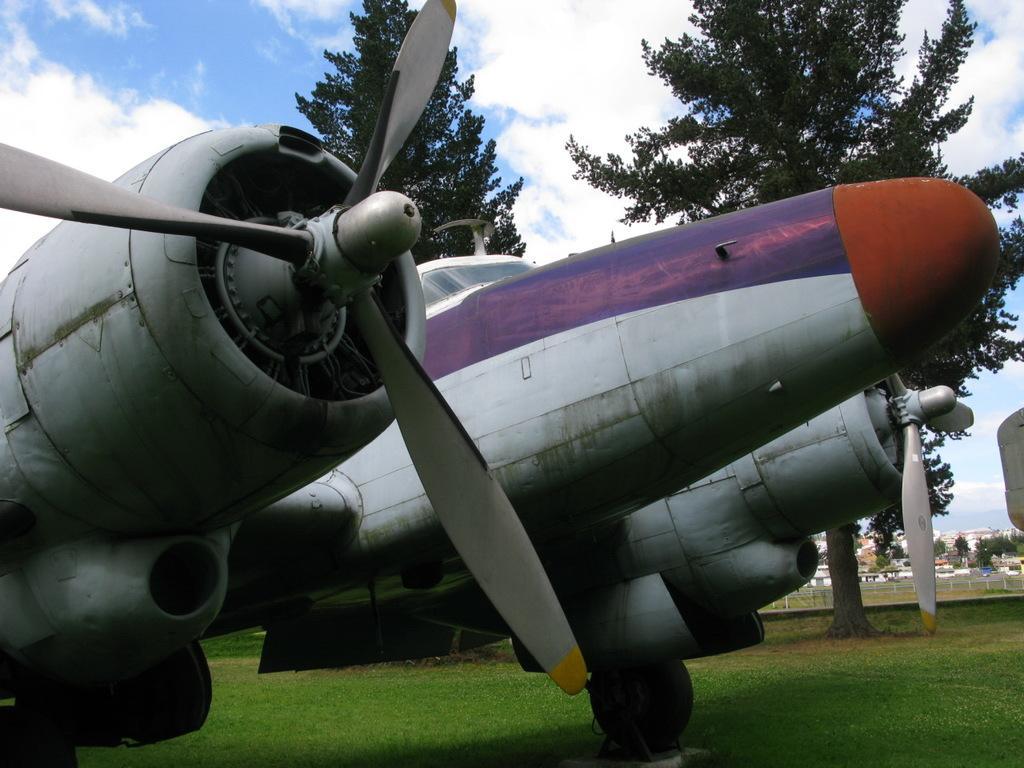Can you describe this image briefly? As we can see in the image there is a plane, grass and trees. In the background there are buildings. At the top there is sky and clouds. 